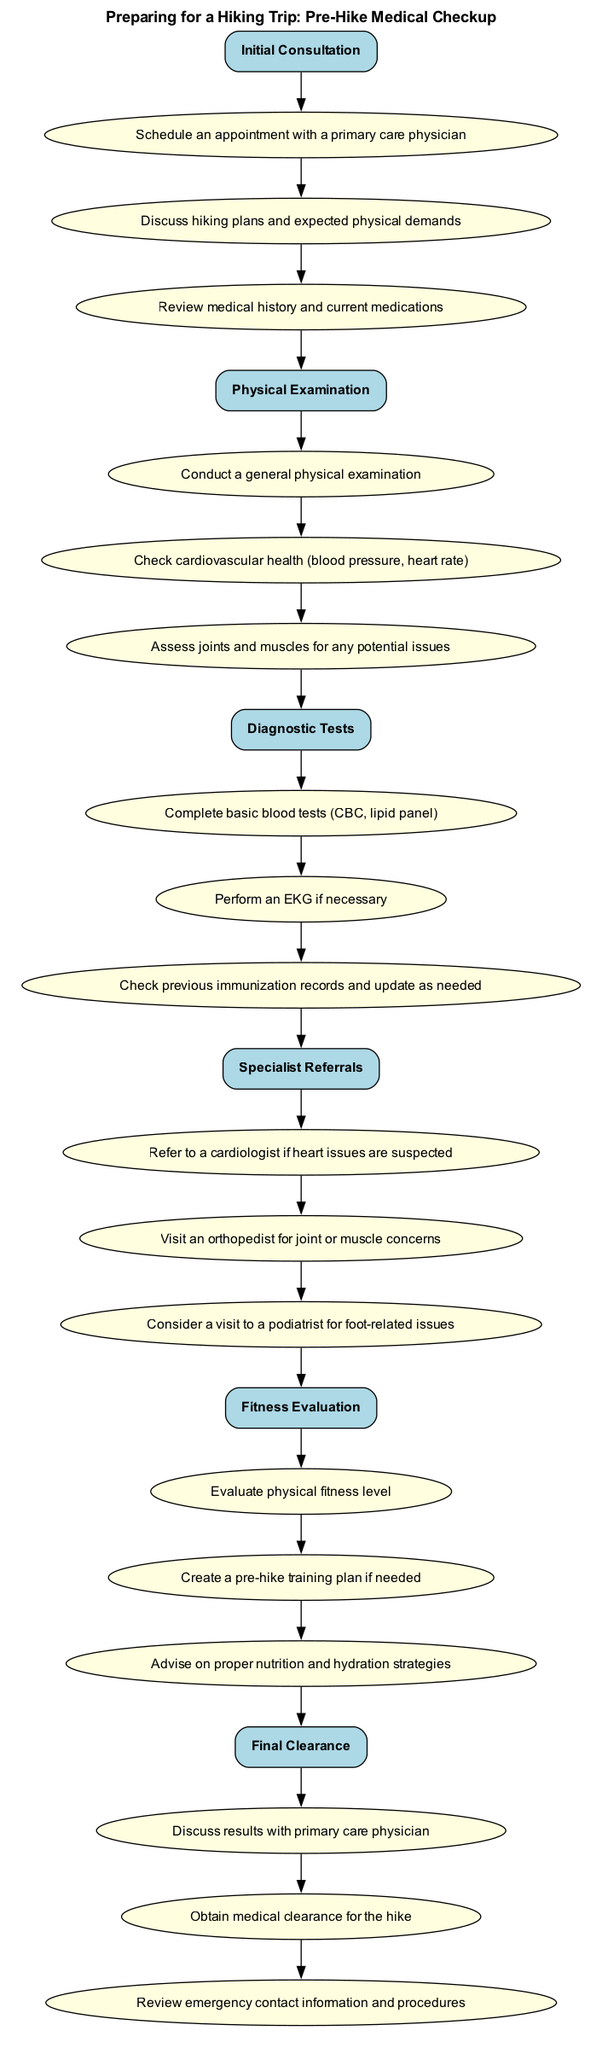What is the first step in the clinical pathway? The first step listed in the clinical pathway is "Initial Consultation". This can be identified as the first node, which is the starting point in the diagram.
Answer: Initial Consultation How many steps are there in total? By counting the number of unique steps provided in the diagram, we see that there are six steps in the clinical pathway.
Answer: 6 What is one of the elements under the "Physical Examination" step? Looking into the "Physical Examination" step, one of the elements listed is "Check cardiovascular health (blood pressure, heart rate)". This is found under the corresponding node in the diagram.
Answer: Check cardiovascular health (blood pressure, heart rate) Which step follows "Diagnostic Tests"? The flow of the diagram indicates that "Specialist Referrals" comes directly after "Diagnostic Tests", connecting the two steps in sequence.
Answer: Specialist Referrals What type of health professional is referred to in the "Specialist Referrals" step for joint or muscle concerns? Under the "Specialist Referrals" step, it specifically mentions visiting an "orthopedist" for joint or muscle concerns, which identifies the type of health professional directly.
Answer: Orthopedist What is the final step in the clinical pathway? The last step noted in the clinical pathway is "Final Clearance", which indicates the completion of all prior steps and decision-making processes involved.
Answer: Final Clearance What is required at the "Final Clearance" step before going hiking? At the "Final Clearance" step, it is required to "Obtain medical clearance for the hike", which indicates a necessary action prior to undertaking the hike.
Answer: Obtain medical clearance for the hike How does the "Fitness Evaluation" step relate to the overall preparation? The "Fitness Evaluation" step addresses both the evaluation of physical fitness and creating a training plan, showing its importance in ensuring individuals are prepared for the hike by outlining necessary physical readiness.
Answer: Evaluates physical fitness level What kind of tests are mentioned in the "Diagnostic Tests" step? The "Diagnostic Tests" step includes completing "basic blood tests (CBC, lipid panel)", which specifies the tests conducted to assess health before hiking.
Answer: Basic blood tests (CBC, lipid panel) 